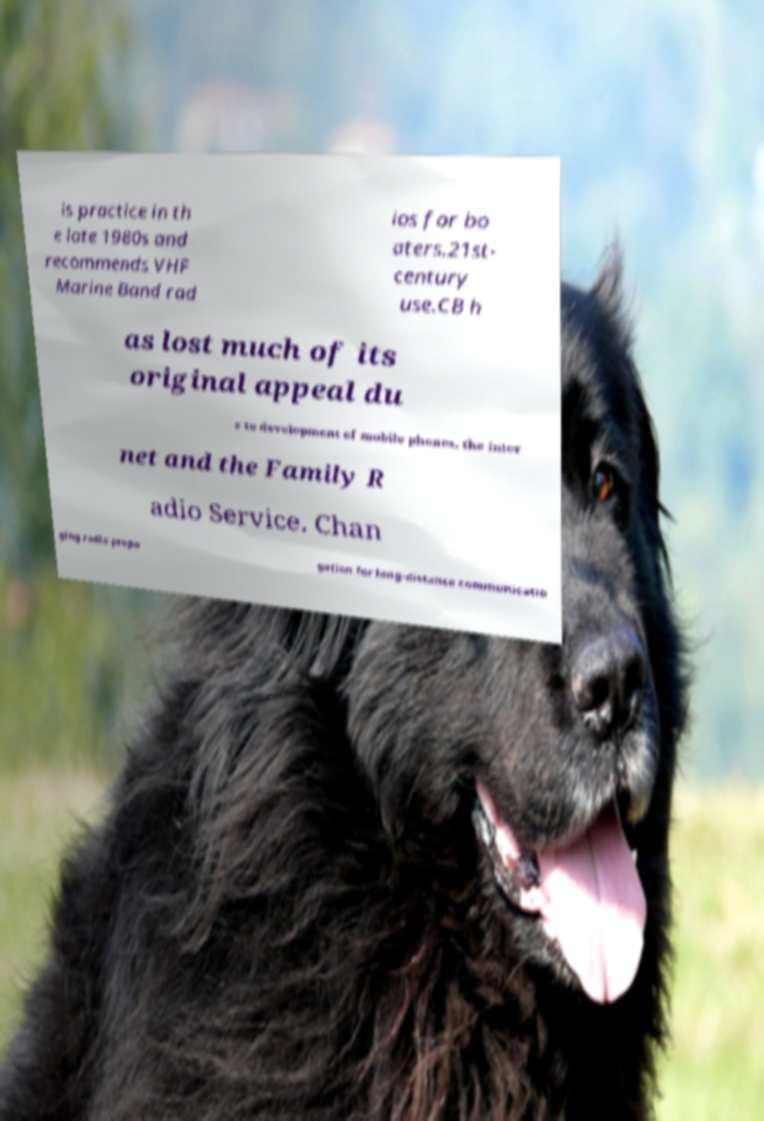Could you assist in decoding the text presented in this image and type it out clearly? is practice in th e late 1980s and recommends VHF Marine Band rad ios for bo aters.21st- century use.CB h as lost much of its original appeal du e to development of mobile phones, the inter net and the Family R adio Service. Chan ging radio propa gation for long-distance communicatio 